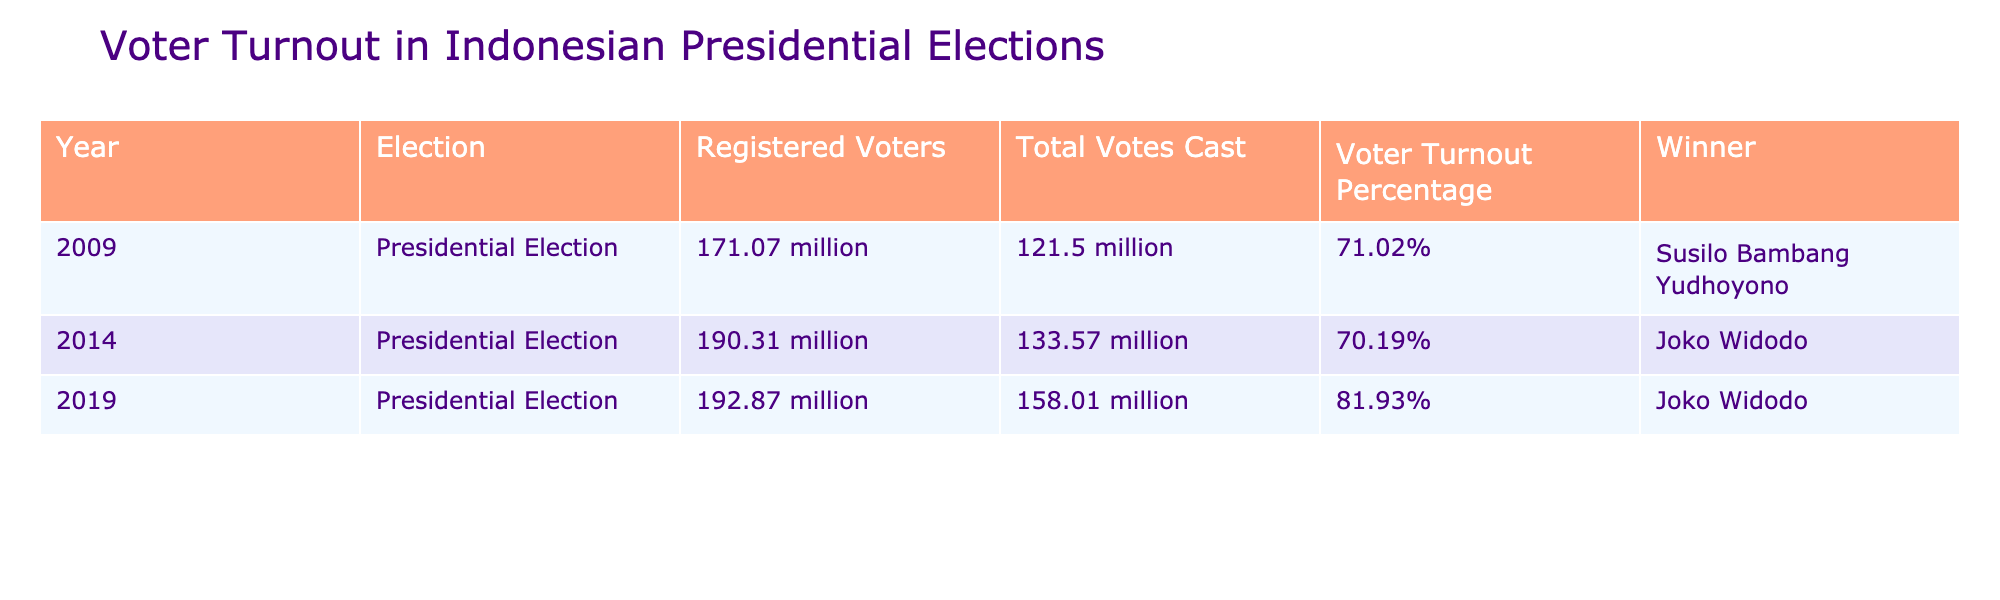What was the voter turnout percentage in the 2019 presidential election? The table shows that the voter turnout percentage for the 2019 election is listed as 81.93%.
Answer: 81.93% Who won the presidential election in 2009? According to the table, Susilo Bambang Yudhoyono won the presidential election in 2009.
Answer: Susilo Bambang Yudhoyono What is the total number of registered voters in the 2014 election? The table indicates that the total number of registered voters in the 2014 election is 190.31 million.
Answer: 190.31 million Which election had the highest voter turnout percentage? From the table data, the 2019 election had the highest voter turnout percentage at 81.93%.
Answer: 2019 election What is the difference in total votes cast between the 2009 and 2014 elections? The total votes cast in 2009 is 121.5 million and in 2014 it is 133.57 million. The difference is 133.57 million - 121.5 million = 12.07 million.
Answer: 12.07 million Was the voter turnout in 2014 higher than in 2009? The voter turnout in 2014 was 70.19%, while in 2009 it was 71.02%. Since 70.19% is less than 71.02%, the answer is no.
Answer: No What was the average voter turnout percentage across the three elections? The voter turnout percentages are 71.02%, 70.19%, and 81.93%. To find the average, sum these percentages (71.02 + 70.19 + 81.93 = 223.14) and divide by 3, resulting in an average of 74.38%.
Answer: 74.38% In which election did Joko Widodo win? The table shows that Joko Widodo won the presidential elections in 2014 and 2019.
Answer: 2014 and 2019 How many more votes were cast in the 2019 election than in the 2014 election? The total votes cast in 2019 is 158.01 million, and in 2014 it is 133.57 million. The difference is 158.01 million - 133.57 million = 24.44 million.
Answer: 24.44 million Is it true that the number of registered voters increased from 2009 to 2014? Yes, the number of registered voters increased from 171.07 million in 2009 to 190.31 million in 2014, which shows an increase.
Answer: Yes 